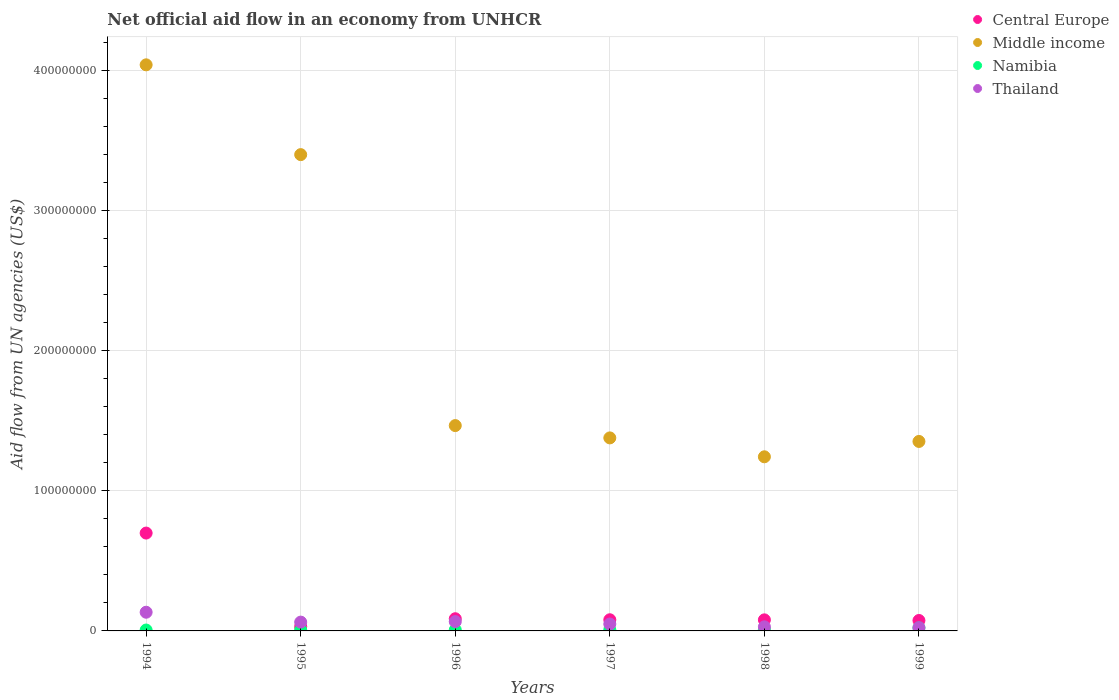What is the net official aid flow in Central Europe in 1995?
Offer a terse response. 3.03e+06. Across all years, what is the maximum net official aid flow in Middle income?
Offer a terse response. 4.04e+08. Across all years, what is the minimum net official aid flow in Namibia?
Provide a short and direct response. 6.40e+05. What is the total net official aid flow in Central Europe in the graph?
Give a very brief answer. 1.05e+08. What is the difference between the net official aid flow in Central Europe in 1994 and the net official aid flow in Middle income in 1999?
Make the answer very short. -6.54e+07. What is the average net official aid flow in Namibia per year?
Your answer should be compact. 1.00e+06. In the year 1997, what is the difference between the net official aid flow in Namibia and net official aid flow in Thailand?
Keep it short and to the point. -4.09e+06. In how many years, is the net official aid flow in Thailand greater than 260000000 US$?
Ensure brevity in your answer.  0. What is the ratio of the net official aid flow in Namibia in 1994 to that in 1999?
Give a very brief answer. 0.29. Is the net official aid flow in Namibia in 1996 less than that in 1999?
Offer a very short reply. Yes. Is the difference between the net official aid flow in Namibia in 1995 and 1997 greater than the difference between the net official aid flow in Thailand in 1995 and 1997?
Provide a short and direct response. No. What is the difference between the highest and the second highest net official aid flow in Namibia?
Your response must be concise. 1.23e+06. What is the difference between the highest and the lowest net official aid flow in Namibia?
Provide a short and direct response. 1.54e+06. Is it the case that in every year, the sum of the net official aid flow in Thailand and net official aid flow in Central Europe  is greater than the sum of net official aid flow in Middle income and net official aid flow in Namibia?
Give a very brief answer. No. Is the net official aid flow in Namibia strictly less than the net official aid flow in Middle income over the years?
Keep it short and to the point. Yes. How many dotlines are there?
Offer a terse response. 4. How many years are there in the graph?
Make the answer very short. 6. What is the difference between two consecutive major ticks on the Y-axis?
Give a very brief answer. 1.00e+08. Are the values on the major ticks of Y-axis written in scientific E-notation?
Offer a very short reply. No. How are the legend labels stacked?
Provide a short and direct response. Vertical. What is the title of the graph?
Provide a short and direct response. Net official aid flow in an economy from UNHCR. Does "Turks and Caicos Islands" appear as one of the legend labels in the graph?
Offer a very short reply. No. What is the label or title of the Y-axis?
Your answer should be very brief. Aid flow from UN agencies (US$). What is the Aid flow from UN agencies (US$) in Central Europe in 1994?
Give a very brief answer. 6.98e+07. What is the Aid flow from UN agencies (US$) in Middle income in 1994?
Ensure brevity in your answer.  4.04e+08. What is the Aid flow from UN agencies (US$) in Namibia in 1994?
Offer a very short reply. 6.40e+05. What is the Aid flow from UN agencies (US$) in Thailand in 1994?
Provide a succinct answer. 1.33e+07. What is the Aid flow from UN agencies (US$) of Central Europe in 1995?
Offer a very short reply. 3.03e+06. What is the Aid flow from UN agencies (US$) in Middle income in 1995?
Provide a succinct answer. 3.40e+08. What is the Aid flow from UN agencies (US$) of Namibia in 1995?
Give a very brief answer. 6.70e+05. What is the Aid flow from UN agencies (US$) of Thailand in 1995?
Your answer should be compact. 6.29e+06. What is the Aid flow from UN agencies (US$) in Central Europe in 1996?
Your answer should be very brief. 8.70e+06. What is the Aid flow from UN agencies (US$) of Middle income in 1996?
Your answer should be very brief. 1.47e+08. What is the Aid flow from UN agencies (US$) in Namibia in 1996?
Your answer should be very brief. 7.50e+05. What is the Aid flow from UN agencies (US$) in Thailand in 1996?
Offer a very short reply. 6.65e+06. What is the Aid flow from UN agencies (US$) in Central Europe in 1997?
Provide a succinct answer. 7.97e+06. What is the Aid flow from UN agencies (US$) in Middle income in 1997?
Make the answer very short. 1.38e+08. What is the Aid flow from UN agencies (US$) in Namibia in 1997?
Make the answer very short. 8.30e+05. What is the Aid flow from UN agencies (US$) of Thailand in 1997?
Make the answer very short. 4.92e+06. What is the Aid flow from UN agencies (US$) of Central Europe in 1998?
Give a very brief answer. 7.90e+06. What is the Aid flow from UN agencies (US$) in Middle income in 1998?
Ensure brevity in your answer.  1.24e+08. What is the Aid flow from UN agencies (US$) in Namibia in 1998?
Your answer should be compact. 9.50e+05. What is the Aid flow from UN agencies (US$) in Thailand in 1998?
Provide a succinct answer. 2.92e+06. What is the Aid flow from UN agencies (US$) in Central Europe in 1999?
Offer a very short reply. 7.45e+06. What is the Aid flow from UN agencies (US$) of Middle income in 1999?
Keep it short and to the point. 1.35e+08. What is the Aid flow from UN agencies (US$) in Namibia in 1999?
Give a very brief answer. 2.18e+06. What is the Aid flow from UN agencies (US$) in Thailand in 1999?
Provide a short and direct response. 2.33e+06. Across all years, what is the maximum Aid flow from UN agencies (US$) of Central Europe?
Your answer should be compact. 6.98e+07. Across all years, what is the maximum Aid flow from UN agencies (US$) of Middle income?
Give a very brief answer. 4.04e+08. Across all years, what is the maximum Aid flow from UN agencies (US$) in Namibia?
Provide a succinct answer. 2.18e+06. Across all years, what is the maximum Aid flow from UN agencies (US$) of Thailand?
Your answer should be compact. 1.33e+07. Across all years, what is the minimum Aid flow from UN agencies (US$) of Central Europe?
Keep it short and to the point. 3.03e+06. Across all years, what is the minimum Aid flow from UN agencies (US$) of Middle income?
Give a very brief answer. 1.24e+08. Across all years, what is the minimum Aid flow from UN agencies (US$) in Namibia?
Provide a short and direct response. 6.40e+05. Across all years, what is the minimum Aid flow from UN agencies (US$) of Thailand?
Offer a very short reply. 2.33e+06. What is the total Aid flow from UN agencies (US$) of Central Europe in the graph?
Give a very brief answer. 1.05e+08. What is the total Aid flow from UN agencies (US$) in Middle income in the graph?
Your answer should be very brief. 1.29e+09. What is the total Aid flow from UN agencies (US$) of Namibia in the graph?
Provide a succinct answer. 6.02e+06. What is the total Aid flow from UN agencies (US$) of Thailand in the graph?
Provide a succinct answer. 3.64e+07. What is the difference between the Aid flow from UN agencies (US$) in Central Europe in 1994 and that in 1995?
Provide a short and direct response. 6.68e+07. What is the difference between the Aid flow from UN agencies (US$) of Middle income in 1994 and that in 1995?
Offer a very short reply. 6.41e+07. What is the difference between the Aid flow from UN agencies (US$) of Namibia in 1994 and that in 1995?
Offer a very short reply. -3.00e+04. What is the difference between the Aid flow from UN agencies (US$) in Thailand in 1994 and that in 1995?
Provide a short and direct response. 7.05e+06. What is the difference between the Aid flow from UN agencies (US$) of Central Europe in 1994 and that in 1996?
Your response must be concise. 6.12e+07. What is the difference between the Aid flow from UN agencies (US$) in Middle income in 1994 and that in 1996?
Your answer should be compact. 2.58e+08. What is the difference between the Aid flow from UN agencies (US$) of Namibia in 1994 and that in 1996?
Give a very brief answer. -1.10e+05. What is the difference between the Aid flow from UN agencies (US$) in Thailand in 1994 and that in 1996?
Offer a very short reply. 6.69e+06. What is the difference between the Aid flow from UN agencies (US$) in Central Europe in 1994 and that in 1997?
Offer a terse response. 6.19e+07. What is the difference between the Aid flow from UN agencies (US$) of Middle income in 1994 and that in 1997?
Make the answer very short. 2.66e+08. What is the difference between the Aid flow from UN agencies (US$) in Thailand in 1994 and that in 1997?
Ensure brevity in your answer.  8.42e+06. What is the difference between the Aid flow from UN agencies (US$) in Central Europe in 1994 and that in 1998?
Make the answer very short. 6.20e+07. What is the difference between the Aid flow from UN agencies (US$) in Middle income in 1994 and that in 1998?
Your answer should be compact. 2.80e+08. What is the difference between the Aid flow from UN agencies (US$) of Namibia in 1994 and that in 1998?
Give a very brief answer. -3.10e+05. What is the difference between the Aid flow from UN agencies (US$) in Thailand in 1994 and that in 1998?
Your answer should be very brief. 1.04e+07. What is the difference between the Aid flow from UN agencies (US$) in Central Europe in 1994 and that in 1999?
Offer a very short reply. 6.24e+07. What is the difference between the Aid flow from UN agencies (US$) in Middle income in 1994 and that in 1999?
Your answer should be very brief. 2.69e+08. What is the difference between the Aid flow from UN agencies (US$) of Namibia in 1994 and that in 1999?
Provide a short and direct response. -1.54e+06. What is the difference between the Aid flow from UN agencies (US$) of Thailand in 1994 and that in 1999?
Ensure brevity in your answer.  1.10e+07. What is the difference between the Aid flow from UN agencies (US$) of Central Europe in 1995 and that in 1996?
Ensure brevity in your answer.  -5.67e+06. What is the difference between the Aid flow from UN agencies (US$) of Middle income in 1995 and that in 1996?
Give a very brief answer. 1.93e+08. What is the difference between the Aid flow from UN agencies (US$) in Thailand in 1995 and that in 1996?
Provide a succinct answer. -3.60e+05. What is the difference between the Aid flow from UN agencies (US$) of Central Europe in 1995 and that in 1997?
Offer a very short reply. -4.94e+06. What is the difference between the Aid flow from UN agencies (US$) of Middle income in 1995 and that in 1997?
Give a very brief answer. 2.02e+08. What is the difference between the Aid flow from UN agencies (US$) of Thailand in 1995 and that in 1997?
Your answer should be compact. 1.37e+06. What is the difference between the Aid flow from UN agencies (US$) of Central Europe in 1995 and that in 1998?
Your answer should be very brief. -4.87e+06. What is the difference between the Aid flow from UN agencies (US$) in Middle income in 1995 and that in 1998?
Your answer should be very brief. 2.16e+08. What is the difference between the Aid flow from UN agencies (US$) of Namibia in 1995 and that in 1998?
Your response must be concise. -2.80e+05. What is the difference between the Aid flow from UN agencies (US$) in Thailand in 1995 and that in 1998?
Make the answer very short. 3.37e+06. What is the difference between the Aid flow from UN agencies (US$) in Central Europe in 1995 and that in 1999?
Provide a short and direct response. -4.42e+06. What is the difference between the Aid flow from UN agencies (US$) in Middle income in 1995 and that in 1999?
Your answer should be very brief. 2.05e+08. What is the difference between the Aid flow from UN agencies (US$) in Namibia in 1995 and that in 1999?
Keep it short and to the point. -1.51e+06. What is the difference between the Aid flow from UN agencies (US$) of Thailand in 1995 and that in 1999?
Offer a terse response. 3.96e+06. What is the difference between the Aid flow from UN agencies (US$) of Central Europe in 1996 and that in 1997?
Provide a succinct answer. 7.30e+05. What is the difference between the Aid flow from UN agencies (US$) of Middle income in 1996 and that in 1997?
Offer a very short reply. 8.79e+06. What is the difference between the Aid flow from UN agencies (US$) of Thailand in 1996 and that in 1997?
Keep it short and to the point. 1.73e+06. What is the difference between the Aid flow from UN agencies (US$) in Middle income in 1996 and that in 1998?
Make the answer very short. 2.23e+07. What is the difference between the Aid flow from UN agencies (US$) of Thailand in 1996 and that in 1998?
Offer a terse response. 3.73e+06. What is the difference between the Aid flow from UN agencies (US$) of Central Europe in 1996 and that in 1999?
Give a very brief answer. 1.25e+06. What is the difference between the Aid flow from UN agencies (US$) in Middle income in 1996 and that in 1999?
Your answer should be compact. 1.13e+07. What is the difference between the Aid flow from UN agencies (US$) in Namibia in 1996 and that in 1999?
Offer a terse response. -1.43e+06. What is the difference between the Aid flow from UN agencies (US$) of Thailand in 1996 and that in 1999?
Your answer should be very brief. 4.32e+06. What is the difference between the Aid flow from UN agencies (US$) in Central Europe in 1997 and that in 1998?
Offer a terse response. 7.00e+04. What is the difference between the Aid flow from UN agencies (US$) of Middle income in 1997 and that in 1998?
Your answer should be compact. 1.35e+07. What is the difference between the Aid flow from UN agencies (US$) of Thailand in 1997 and that in 1998?
Give a very brief answer. 2.00e+06. What is the difference between the Aid flow from UN agencies (US$) in Central Europe in 1997 and that in 1999?
Your response must be concise. 5.20e+05. What is the difference between the Aid flow from UN agencies (US$) in Middle income in 1997 and that in 1999?
Give a very brief answer. 2.53e+06. What is the difference between the Aid flow from UN agencies (US$) of Namibia in 1997 and that in 1999?
Give a very brief answer. -1.35e+06. What is the difference between the Aid flow from UN agencies (US$) of Thailand in 1997 and that in 1999?
Provide a short and direct response. 2.59e+06. What is the difference between the Aid flow from UN agencies (US$) in Middle income in 1998 and that in 1999?
Your answer should be very brief. -1.10e+07. What is the difference between the Aid flow from UN agencies (US$) in Namibia in 1998 and that in 1999?
Your answer should be compact. -1.23e+06. What is the difference between the Aid flow from UN agencies (US$) of Thailand in 1998 and that in 1999?
Offer a terse response. 5.90e+05. What is the difference between the Aid flow from UN agencies (US$) of Central Europe in 1994 and the Aid flow from UN agencies (US$) of Middle income in 1995?
Offer a terse response. -2.70e+08. What is the difference between the Aid flow from UN agencies (US$) of Central Europe in 1994 and the Aid flow from UN agencies (US$) of Namibia in 1995?
Offer a terse response. 6.92e+07. What is the difference between the Aid flow from UN agencies (US$) of Central Europe in 1994 and the Aid flow from UN agencies (US$) of Thailand in 1995?
Your answer should be very brief. 6.36e+07. What is the difference between the Aid flow from UN agencies (US$) of Middle income in 1994 and the Aid flow from UN agencies (US$) of Namibia in 1995?
Provide a short and direct response. 4.03e+08. What is the difference between the Aid flow from UN agencies (US$) in Middle income in 1994 and the Aid flow from UN agencies (US$) in Thailand in 1995?
Offer a terse response. 3.98e+08. What is the difference between the Aid flow from UN agencies (US$) of Namibia in 1994 and the Aid flow from UN agencies (US$) of Thailand in 1995?
Give a very brief answer. -5.65e+06. What is the difference between the Aid flow from UN agencies (US$) of Central Europe in 1994 and the Aid flow from UN agencies (US$) of Middle income in 1996?
Provide a short and direct response. -7.67e+07. What is the difference between the Aid flow from UN agencies (US$) in Central Europe in 1994 and the Aid flow from UN agencies (US$) in Namibia in 1996?
Make the answer very short. 6.91e+07. What is the difference between the Aid flow from UN agencies (US$) of Central Europe in 1994 and the Aid flow from UN agencies (US$) of Thailand in 1996?
Your answer should be compact. 6.32e+07. What is the difference between the Aid flow from UN agencies (US$) in Middle income in 1994 and the Aid flow from UN agencies (US$) in Namibia in 1996?
Ensure brevity in your answer.  4.03e+08. What is the difference between the Aid flow from UN agencies (US$) of Middle income in 1994 and the Aid flow from UN agencies (US$) of Thailand in 1996?
Provide a succinct answer. 3.97e+08. What is the difference between the Aid flow from UN agencies (US$) in Namibia in 1994 and the Aid flow from UN agencies (US$) in Thailand in 1996?
Your response must be concise. -6.01e+06. What is the difference between the Aid flow from UN agencies (US$) of Central Europe in 1994 and the Aid flow from UN agencies (US$) of Middle income in 1997?
Offer a very short reply. -6.79e+07. What is the difference between the Aid flow from UN agencies (US$) in Central Europe in 1994 and the Aid flow from UN agencies (US$) in Namibia in 1997?
Your response must be concise. 6.90e+07. What is the difference between the Aid flow from UN agencies (US$) of Central Europe in 1994 and the Aid flow from UN agencies (US$) of Thailand in 1997?
Ensure brevity in your answer.  6.49e+07. What is the difference between the Aid flow from UN agencies (US$) in Middle income in 1994 and the Aid flow from UN agencies (US$) in Namibia in 1997?
Ensure brevity in your answer.  4.03e+08. What is the difference between the Aid flow from UN agencies (US$) in Middle income in 1994 and the Aid flow from UN agencies (US$) in Thailand in 1997?
Provide a succinct answer. 3.99e+08. What is the difference between the Aid flow from UN agencies (US$) in Namibia in 1994 and the Aid flow from UN agencies (US$) in Thailand in 1997?
Ensure brevity in your answer.  -4.28e+06. What is the difference between the Aid flow from UN agencies (US$) in Central Europe in 1994 and the Aid flow from UN agencies (US$) in Middle income in 1998?
Offer a very short reply. -5.44e+07. What is the difference between the Aid flow from UN agencies (US$) of Central Europe in 1994 and the Aid flow from UN agencies (US$) of Namibia in 1998?
Your answer should be compact. 6.89e+07. What is the difference between the Aid flow from UN agencies (US$) of Central Europe in 1994 and the Aid flow from UN agencies (US$) of Thailand in 1998?
Offer a terse response. 6.69e+07. What is the difference between the Aid flow from UN agencies (US$) in Middle income in 1994 and the Aid flow from UN agencies (US$) in Namibia in 1998?
Give a very brief answer. 4.03e+08. What is the difference between the Aid flow from UN agencies (US$) of Middle income in 1994 and the Aid flow from UN agencies (US$) of Thailand in 1998?
Your answer should be compact. 4.01e+08. What is the difference between the Aid flow from UN agencies (US$) in Namibia in 1994 and the Aid flow from UN agencies (US$) in Thailand in 1998?
Provide a short and direct response. -2.28e+06. What is the difference between the Aid flow from UN agencies (US$) of Central Europe in 1994 and the Aid flow from UN agencies (US$) of Middle income in 1999?
Ensure brevity in your answer.  -6.54e+07. What is the difference between the Aid flow from UN agencies (US$) of Central Europe in 1994 and the Aid flow from UN agencies (US$) of Namibia in 1999?
Your answer should be very brief. 6.77e+07. What is the difference between the Aid flow from UN agencies (US$) in Central Europe in 1994 and the Aid flow from UN agencies (US$) in Thailand in 1999?
Your answer should be compact. 6.75e+07. What is the difference between the Aid flow from UN agencies (US$) of Middle income in 1994 and the Aid flow from UN agencies (US$) of Namibia in 1999?
Offer a very short reply. 4.02e+08. What is the difference between the Aid flow from UN agencies (US$) of Middle income in 1994 and the Aid flow from UN agencies (US$) of Thailand in 1999?
Your answer should be compact. 4.02e+08. What is the difference between the Aid flow from UN agencies (US$) in Namibia in 1994 and the Aid flow from UN agencies (US$) in Thailand in 1999?
Provide a succinct answer. -1.69e+06. What is the difference between the Aid flow from UN agencies (US$) in Central Europe in 1995 and the Aid flow from UN agencies (US$) in Middle income in 1996?
Your answer should be very brief. -1.44e+08. What is the difference between the Aid flow from UN agencies (US$) of Central Europe in 1995 and the Aid flow from UN agencies (US$) of Namibia in 1996?
Provide a short and direct response. 2.28e+06. What is the difference between the Aid flow from UN agencies (US$) in Central Europe in 1995 and the Aid flow from UN agencies (US$) in Thailand in 1996?
Provide a short and direct response. -3.62e+06. What is the difference between the Aid flow from UN agencies (US$) of Middle income in 1995 and the Aid flow from UN agencies (US$) of Namibia in 1996?
Your response must be concise. 3.39e+08. What is the difference between the Aid flow from UN agencies (US$) in Middle income in 1995 and the Aid flow from UN agencies (US$) in Thailand in 1996?
Offer a very short reply. 3.33e+08. What is the difference between the Aid flow from UN agencies (US$) in Namibia in 1995 and the Aid flow from UN agencies (US$) in Thailand in 1996?
Your response must be concise. -5.98e+06. What is the difference between the Aid flow from UN agencies (US$) in Central Europe in 1995 and the Aid flow from UN agencies (US$) in Middle income in 1997?
Offer a terse response. -1.35e+08. What is the difference between the Aid flow from UN agencies (US$) of Central Europe in 1995 and the Aid flow from UN agencies (US$) of Namibia in 1997?
Ensure brevity in your answer.  2.20e+06. What is the difference between the Aid flow from UN agencies (US$) of Central Europe in 1995 and the Aid flow from UN agencies (US$) of Thailand in 1997?
Give a very brief answer. -1.89e+06. What is the difference between the Aid flow from UN agencies (US$) of Middle income in 1995 and the Aid flow from UN agencies (US$) of Namibia in 1997?
Offer a terse response. 3.39e+08. What is the difference between the Aid flow from UN agencies (US$) in Middle income in 1995 and the Aid flow from UN agencies (US$) in Thailand in 1997?
Offer a very short reply. 3.35e+08. What is the difference between the Aid flow from UN agencies (US$) of Namibia in 1995 and the Aid flow from UN agencies (US$) of Thailand in 1997?
Your response must be concise. -4.25e+06. What is the difference between the Aid flow from UN agencies (US$) in Central Europe in 1995 and the Aid flow from UN agencies (US$) in Middle income in 1998?
Your answer should be very brief. -1.21e+08. What is the difference between the Aid flow from UN agencies (US$) in Central Europe in 1995 and the Aid flow from UN agencies (US$) in Namibia in 1998?
Provide a short and direct response. 2.08e+06. What is the difference between the Aid flow from UN agencies (US$) of Middle income in 1995 and the Aid flow from UN agencies (US$) of Namibia in 1998?
Make the answer very short. 3.39e+08. What is the difference between the Aid flow from UN agencies (US$) of Middle income in 1995 and the Aid flow from UN agencies (US$) of Thailand in 1998?
Your response must be concise. 3.37e+08. What is the difference between the Aid flow from UN agencies (US$) of Namibia in 1995 and the Aid flow from UN agencies (US$) of Thailand in 1998?
Give a very brief answer. -2.25e+06. What is the difference between the Aid flow from UN agencies (US$) in Central Europe in 1995 and the Aid flow from UN agencies (US$) in Middle income in 1999?
Offer a very short reply. -1.32e+08. What is the difference between the Aid flow from UN agencies (US$) in Central Europe in 1995 and the Aid flow from UN agencies (US$) in Namibia in 1999?
Provide a succinct answer. 8.50e+05. What is the difference between the Aid flow from UN agencies (US$) in Central Europe in 1995 and the Aid flow from UN agencies (US$) in Thailand in 1999?
Your answer should be very brief. 7.00e+05. What is the difference between the Aid flow from UN agencies (US$) in Middle income in 1995 and the Aid flow from UN agencies (US$) in Namibia in 1999?
Make the answer very short. 3.38e+08. What is the difference between the Aid flow from UN agencies (US$) of Middle income in 1995 and the Aid flow from UN agencies (US$) of Thailand in 1999?
Keep it short and to the point. 3.38e+08. What is the difference between the Aid flow from UN agencies (US$) in Namibia in 1995 and the Aid flow from UN agencies (US$) in Thailand in 1999?
Offer a very short reply. -1.66e+06. What is the difference between the Aid flow from UN agencies (US$) of Central Europe in 1996 and the Aid flow from UN agencies (US$) of Middle income in 1997?
Offer a very short reply. -1.29e+08. What is the difference between the Aid flow from UN agencies (US$) in Central Europe in 1996 and the Aid flow from UN agencies (US$) in Namibia in 1997?
Provide a short and direct response. 7.87e+06. What is the difference between the Aid flow from UN agencies (US$) of Central Europe in 1996 and the Aid flow from UN agencies (US$) of Thailand in 1997?
Your response must be concise. 3.78e+06. What is the difference between the Aid flow from UN agencies (US$) of Middle income in 1996 and the Aid flow from UN agencies (US$) of Namibia in 1997?
Keep it short and to the point. 1.46e+08. What is the difference between the Aid flow from UN agencies (US$) of Middle income in 1996 and the Aid flow from UN agencies (US$) of Thailand in 1997?
Your response must be concise. 1.42e+08. What is the difference between the Aid flow from UN agencies (US$) of Namibia in 1996 and the Aid flow from UN agencies (US$) of Thailand in 1997?
Provide a short and direct response. -4.17e+06. What is the difference between the Aid flow from UN agencies (US$) in Central Europe in 1996 and the Aid flow from UN agencies (US$) in Middle income in 1998?
Ensure brevity in your answer.  -1.16e+08. What is the difference between the Aid flow from UN agencies (US$) of Central Europe in 1996 and the Aid flow from UN agencies (US$) of Namibia in 1998?
Provide a short and direct response. 7.75e+06. What is the difference between the Aid flow from UN agencies (US$) in Central Europe in 1996 and the Aid flow from UN agencies (US$) in Thailand in 1998?
Give a very brief answer. 5.78e+06. What is the difference between the Aid flow from UN agencies (US$) in Middle income in 1996 and the Aid flow from UN agencies (US$) in Namibia in 1998?
Ensure brevity in your answer.  1.46e+08. What is the difference between the Aid flow from UN agencies (US$) in Middle income in 1996 and the Aid flow from UN agencies (US$) in Thailand in 1998?
Provide a short and direct response. 1.44e+08. What is the difference between the Aid flow from UN agencies (US$) of Namibia in 1996 and the Aid flow from UN agencies (US$) of Thailand in 1998?
Your answer should be compact. -2.17e+06. What is the difference between the Aid flow from UN agencies (US$) in Central Europe in 1996 and the Aid flow from UN agencies (US$) in Middle income in 1999?
Provide a short and direct response. -1.27e+08. What is the difference between the Aid flow from UN agencies (US$) in Central Europe in 1996 and the Aid flow from UN agencies (US$) in Namibia in 1999?
Your answer should be very brief. 6.52e+06. What is the difference between the Aid flow from UN agencies (US$) of Central Europe in 1996 and the Aid flow from UN agencies (US$) of Thailand in 1999?
Your response must be concise. 6.37e+06. What is the difference between the Aid flow from UN agencies (US$) in Middle income in 1996 and the Aid flow from UN agencies (US$) in Namibia in 1999?
Offer a terse response. 1.44e+08. What is the difference between the Aid flow from UN agencies (US$) in Middle income in 1996 and the Aid flow from UN agencies (US$) in Thailand in 1999?
Keep it short and to the point. 1.44e+08. What is the difference between the Aid flow from UN agencies (US$) of Namibia in 1996 and the Aid flow from UN agencies (US$) of Thailand in 1999?
Ensure brevity in your answer.  -1.58e+06. What is the difference between the Aid flow from UN agencies (US$) in Central Europe in 1997 and the Aid flow from UN agencies (US$) in Middle income in 1998?
Keep it short and to the point. -1.16e+08. What is the difference between the Aid flow from UN agencies (US$) in Central Europe in 1997 and the Aid flow from UN agencies (US$) in Namibia in 1998?
Offer a terse response. 7.02e+06. What is the difference between the Aid flow from UN agencies (US$) of Central Europe in 1997 and the Aid flow from UN agencies (US$) of Thailand in 1998?
Keep it short and to the point. 5.05e+06. What is the difference between the Aid flow from UN agencies (US$) in Middle income in 1997 and the Aid flow from UN agencies (US$) in Namibia in 1998?
Provide a succinct answer. 1.37e+08. What is the difference between the Aid flow from UN agencies (US$) in Middle income in 1997 and the Aid flow from UN agencies (US$) in Thailand in 1998?
Your response must be concise. 1.35e+08. What is the difference between the Aid flow from UN agencies (US$) in Namibia in 1997 and the Aid flow from UN agencies (US$) in Thailand in 1998?
Your answer should be compact. -2.09e+06. What is the difference between the Aid flow from UN agencies (US$) of Central Europe in 1997 and the Aid flow from UN agencies (US$) of Middle income in 1999?
Provide a short and direct response. -1.27e+08. What is the difference between the Aid flow from UN agencies (US$) of Central Europe in 1997 and the Aid flow from UN agencies (US$) of Namibia in 1999?
Keep it short and to the point. 5.79e+06. What is the difference between the Aid flow from UN agencies (US$) of Central Europe in 1997 and the Aid flow from UN agencies (US$) of Thailand in 1999?
Make the answer very short. 5.64e+06. What is the difference between the Aid flow from UN agencies (US$) of Middle income in 1997 and the Aid flow from UN agencies (US$) of Namibia in 1999?
Ensure brevity in your answer.  1.36e+08. What is the difference between the Aid flow from UN agencies (US$) of Middle income in 1997 and the Aid flow from UN agencies (US$) of Thailand in 1999?
Your response must be concise. 1.35e+08. What is the difference between the Aid flow from UN agencies (US$) in Namibia in 1997 and the Aid flow from UN agencies (US$) in Thailand in 1999?
Offer a terse response. -1.50e+06. What is the difference between the Aid flow from UN agencies (US$) in Central Europe in 1998 and the Aid flow from UN agencies (US$) in Middle income in 1999?
Offer a very short reply. -1.27e+08. What is the difference between the Aid flow from UN agencies (US$) of Central Europe in 1998 and the Aid flow from UN agencies (US$) of Namibia in 1999?
Offer a terse response. 5.72e+06. What is the difference between the Aid flow from UN agencies (US$) in Central Europe in 1998 and the Aid flow from UN agencies (US$) in Thailand in 1999?
Your response must be concise. 5.57e+06. What is the difference between the Aid flow from UN agencies (US$) of Middle income in 1998 and the Aid flow from UN agencies (US$) of Namibia in 1999?
Make the answer very short. 1.22e+08. What is the difference between the Aid flow from UN agencies (US$) of Middle income in 1998 and the Aid flow from UN agencies (US$) of Thailand in 1999?
Your answer should be compact. 1.22e+08. What is the difference between the Aid flow from UN agencies (US$) in Namibia in 1998 and the Aid flow from UN agencies (US$) in Thailand in 1999?
Make the answer very short. -1.38e+06. What is the average Aid flow from UN agencies (US$) of Central Europe per year?
Give a very brief answer. 1.75e+07. What is the average Aid flow from UN agencies (US$) of Middle income per year?
Make the answer very short. 2.15e+08. What is the average Aid flow from UN agencies (US$) of Namibia per year?
Make the answer very short. 1.00e+06. What is the average Aid flow from UN agencies (US$) of Thailand per year?
Offer a terse response. 6.08e+06. In the year 1994, what is the difference between the Aid flow from UN agencies (US$) of Central Europe and Aid flow from UN agencies (US$) of Middle income?
Give a very brief answer. -3.34e+08. In the year 1994, what is the difference between the Aid flow from UN agencies (US$) of Central Europe and Aid flow from UN agencies (US$) of Namibia?
Keep it short and to the point. 6.92e+07. In the year 1994, what is the difference between the Aid flow from UN agencies (US$) in Central Europe and Aid flow from UN agencies (US$) in Thailand?
Offer a very short reply. 5.65e+07. In the year 1994, what is the difference between the Aid flow from UN agencies (US$) in Middle income and Aid flow from UN agencies (US$) in Namibia?
Your response must be concise. 4.03e+08. In the year 1994, what is the difference between the Aid flow from UN agencies (US$) in Middle income and Aid flow from UN agencies (US$) in Thailand?
Ensure brevity in your answer.  3.91e+08. In the year 1994, what is the difference between the Aid flow from UN agencies (US$) in Namibia and Aid flow from UN agencies (US$) in Thailand?
Provide a short and direct response. -1.27e+07. In the year 1995, what is the difference between the Aid flow from UN agencies (US$) in Central Europe and Aid flow from UN agencies (US$) in Middle income?
Provide a succinct answer. -3.37e+08. In the year 1995, what is the difference between the Aid flow from UN agencies (US$) of Central Europe and Aid flow from UN agencies (US$) of Namibia?
Your answer should be very brief. 2.36e+06. In the year 1995, what is the difference between the Aid flow from UN agencies (US$) of Central Europe and Aid flow from UN agencies (US$) of Thailand?
Make the answer very short. -3.26e+06. In the year 1995, what is the difference between the Aid flow from UN agencies (US$) of Middle income and Aid flow from UN agencies (US$) of Namibia?
Provide a short and direct response. 3.39e+08. In the year 1995, what is the difference between the Aid flow from UN agencies (US$) in Middle income and Aid flow from UN agencies (US$) in Thailand?
Your answer should be compact. 3.34e+08. In the year 1995, what is the difference between the Aid flow from UN agencies (US$) in Namibia and Aid flow from UN agencies (US$) in Thailand?
Keep it short and to the point. -5.62e+06. In the year 1996, what is the difference between the Aid flow from UN agencies (US$) in Central Europe and Aid flow from UN agencies (US$) in Middle income?
Provide a succinct answer. -1.38e+08. In the year 1996, what is the difference between the Aid flow from UN agencies (US$) of Central Europe and Aid flow from UN agencies (US$) of Namibia?
Your answer should be compact. 7.95e+06. In the year 1996, what is the difference between the Aid flow from UN agencies (US$) in Central Europe and Aid flow from UN agencies (US$) in Thailand?
Provide a short and direct response. 2.05e+06. In the year 1996, what is the difference between the Aid flow from UN agencies (US$) in Middle income and Aid flow from UN agencies (US$) in Namibia?
Ensure brevity in your answer.  1.46e+08. In the year 1996, what is the difference between the Aid flow from UN agencies (US$) in Middle income and Aid flow from UN agencies (US$) in Thailand?
Offer a terse response. 1.40e+08. In the year 1996, what is the difference between the Aid flow from UN agencies (US$) in Namibia and Aid flow from UN agencies (US$) in Thailand?
Offer a terse response. -5.90e+06. In the year 1997, what is the difference between the Aid flow from UN agencies (US$) in Central Europe and Aid flow from UN agencies (US$) in Middle income?
Your answer should be very brief. -1.30e+08. In the year 1997, what is the difference between the Aid flow from UN agencies (US$) of Central Europe and Aid flow from UN agencies (US$) of Namibia?
Provide a short and direct response. 7.14e+06. In the year 1997, what is the difference between the Aid flow from UN agencies (US$) in Central Europe and Aid flow from UN agencies (US$) in Thailand?
Make the answer very short. 3.05e+06. In the year 1997, what is the difference between the Aid flow from UN agencies (US$) in Middle income and Aid flow from UN agencies (US$) in Namibia?
Provide a short and direct response. 1.37e+08. In the year 1997, what is the difference between the Aid flow from UN agencies (US$) of Middle income and Aid flow from UN agencies (US$) of Thailand?
Offer a terse response. 1.33e+08. In the year 1997, what is the difference between the Aid flow from UN agencies (US$) in Namibia and Aid flow from UN agencies (US$) in Thailand?
Your response must be concise. -4.09e+06. In the year 1998, what is the difference between the Aid flow from UN agencies (US$) of Central Europe and Aid flow from UN agencies (US$) of Middle income?
Your answer should be very brief. -1.16e+08. In the year 1998, what is the difference between the Aid flow from UN agencies (US$) of Central Europe and Aid flow from UN agencies (US$) of Namibia?
Offer a very short reply. 6.95e+06. In the year 1998, what is the difference between the Aid flow from UN agencies (US$) in Central Europe and Aid flow from UN agencies (US$) in Thailand?
Make the answer very short. 4.98e+06. In the year 1998, what is the difference between the Aid flow from UN agencies (US$) of Middle income and Aid flow from UN agencies (US$) of Namibia?
Make the answer very short. 1.23e+08. In the year 1998, what is the difference between the Aid flow from UN agencies (US$) in Middle income and Aid flow from UN agencies (US$) in Thailand?
Keep it short and to the point. 1.21e+08. In the year 1998, what is the difference between the Aid flow from UN agencies (US$) of Namibia and Aid flow from UN agencies (US$) of Thailand?
Your answer should be very brief. -1.97e+06. In the year 1999, what is the difference between the Aid flow from UN agencies (US$) of Central Europe and Aid flow from UN agencies (US$) of Middle income?
Provide a succinct answer. -1.28e+08. In the year 1999, what is the difference between the Aid flow from UN agencies (US$) in Central Europe and Aid flow from UN agencies (US$) in Namibia?
Provide a succinct answer. 5.27e+06. In the year 1999, what is the difference between the Aid flow from UN agencies (US$) in Central Europe and Aid flow from UN agencies (US$) in Thailand?
Your response must be concise. 5.12e+06. In the year 1999, what is the difference between the Aid flow from UN agencies (US$) of Middle income and Aid flow from UN agencies (US$) of Namibia?
Offer a very short reply. 1.33e+08. In the year 1999, what is the difference between the Aid flow from UN agencies (US$) of Middle income and Aid flow from UN agencies (US$) of Thailand?
Your response must be concise. 1.33e+08. In the year 1999, what is the difference between the Aid flow from UN agencies (US$) of Namibia and Aid flow from UN agencies (US$) of Thailand?
Provide a short and direct response. -1.50e+05. What is the ratio of the Aid flow from UN agencies (US$) of Central Europe in 1994 to that in 1995?
Ensure brevity in your answer.  23.05. What is the ratio of the Aid flow from UN agencies (US$) of Middle income in 1994 to that in 1995?
Give a very brief answer. 1.19. What is the ratio of the Aid flow from UN agencies (US$) in Namibia in 1994 to that in 1995?
Keep it short and to the point. 0.96. What is the ratio of the Aid flow from UN agencies (US$) of Thailand in 1994 to that in 1995?
Provide a short and direct response. 2.12. What is the ratio of the Aid flow from UN agencies (US$) in Central Europe in 1994 to that in 1996?
Give a very brief answer. 8.03. What is the ratio of the Aid flow from UN agencies (US$) of Middle income in 1994 to that in 1996?
Your response must be concise. 2.76. What is the ratio of the Aid flow from UN agencies (US$) in Namibia in 1994 to that in 1996?
Offer a terse response. 0.85. What is the ratio of the Aid flow from UN agencies (US$) in Thailand in 1994 to that in 1996?
Your answer should be very brief. 2.01. What is the ratio of the Aid flow from UN agencies (US$) of Central Europe in 1994 to that in 1997?
Give a very brief answer. 8.76. What is the ratio of the Aid flow from UN agencies (US$) of Middle income in 1994 to that in 1997?
Make the answer very short. 2.93. What is the ratio of the Aid flow from UN agencies (US$) of Namibia in 1994 to that in 1997?
Offer a very short reply. 0.77. What is the ratio of the Aid flow from UN agencies (US$) in Thailand in 1994 to that in 1997?
Ensure brevity in your answer.  2.71. What is the ratio of the Aid flow from UN agencies (US$) of Central Europe in 1994 to that in 1998?
Your response must be concise. 8.84. What is the ratio of the Aid flow from UN agencies (US$) in Middle income in 1994 to that in 1998?
Give a very brief answer. 3.25. What is the ratio of the Aid flow from UN agencies (US$) of Namibia in 1994 to that in 1998?
Your answer should be compact. 0.67. What is the ratio of the Aid flow from UN agencies (US$) of Thailand in 1994 to that in 1998?
Ensure brevity in your answer.  4.57. What is the ratio of the Aid flow from UN agencies (US$) of Central Europe in 1994 to that in 1999?
Offer a very short reply. 9.38. What is the ratio of the Aid flow from UN agencies (US$) of Middle income in 1994 to that in 1999?
Give a very brief answer. 2.99. What is the ratio of the Aid flow from UN agencies (US$) of Namibia in 1994 to that in 1999?
Ensure brevity in your answer.  0.29. What is the ratio of the Aid flow from UN agencies (US$) of Thailand in 1994 to that in 1999?
Provide a short and direct response. 5.73. What is the ratio of the Aid flow from UN agencies (US$) of Central Europe in 1995 to that in 1996?
Keep it short and to the point. 0.35. What is the ratio of the Aid flow from UN agencies (US$) of Middle income in 1995 to that in 1996?
Provide a succinct answer. 2.32. What is the ratio of the Aid flow from UN agencies (US$) in Namibia in 1995 to that in 1996?
Make the answer very short. 0.89. What is the ratio of the Aid flow from UN agencies (US$) in Thailand in 1995 to that in 1996?
Provide a succinct answer. 0.95. What is the ratio of the Aid flow from UN agencies (US$) of Central Europe in 1995 to that in 1997?
Offer a terse response. 0.38. What is the ratio of the Aid flow from UN agencies (US$) in Middle income in 1995 to that in 1997?
Ensure brevity in your answer.  2.47. What is the ratio of the Aid flow from UN agencies (US$) of Namibia in 1995 to that in 1997?
Offer a very short reply. 0.81. What is the ratio of the Aid flow from UN agencies (US$) of Thailand in 1995 to that in 1997?
Provide a succinct answer. 1.28. What is the ratio of the Aid flow from UN agencies (US$) of Central Europe in 1995 to that in 1998?
Your answer should be compact. 0.38. What is the ratio of the Aid flow from UN agencies (US$) of Middle income in 1995 to that in 1998?
Give a very brief answer. 2.74. What is the ratio of the Aid flow from UN agencies (US$) in Namibia in 1995 to that in 1998?
Give a very brief answer. 0.71. What is the ratio of the Aid flow from UN agencies (US$) in Thailand in 1995 to that in 1998?
Make the answer very short. 2.15. What is the ratio of the Aid flow from UN agencies (US$) in Central Europe in 1995 to that in 1999?
Provide a short and direct response. 0.41. What is the ratio of the Aid flow from UN agencies (US$) in Middle income in 1995 to that in 1999?
Provide a short and direct response. 2.51. What is the ratio of the Aid flow from UN agencies (US$) of Namibia in 1995 to that in 1999?
Your answer should be compact. 0.31. What is the ratio of the Aid flow from UN agencies (US$) of Thailand in 1995 to that in 1999?
Offer a very short reply. 2.7. What is the ratio of the Aid flow from UN agencies (US$) of Central Europe in 1996 to that in 1997?
Offer a very short reply. 1.09. What is the ratio of the Aid flow from UN agencies (US$) in Middle income in 1996 to that in 1997?
Your response must be concise. 1.06. What is the ratio of the Aid flow from UN agencies (US$) of Namibia in 1996 to that in 1997?
Provide a succinct answer. 0.9. What is the ratio of the Aid flow from UN agencies (US$) of Thailand in 1996 to that in 1997?
Offer a terse response. 1.35. What is the ratio of the Aid flow from UN agencies (US$) of Central Europe in 1996 to that in 1998?
Provide a succinct answer. 1.1. What is the ratio of the Aid flow from UN agencies (US$) in Middle income in 1996 to that in 1998?
Provide a short and direct response. 1.18. What is the ratio of the Aid flow from UN agencies (US$) of Namibia in 1996 to that in 1998?
Offer a very short reply. 0.79. What is the ratio of the Aid flow from UN agencies (US$) in Thailand in 1996 to that in 1998?
Offer a very short reply. 2.28. What is the ratio of the Aid flow from UN agencies (US$) in Central Europe in 1996 to that in 1999?
Your answer should be compact. 1.17. What is the ratio of the Aid flow from UN agencies (US$) of Middle income in 1996 to that in 1999?
Ensure brevity in your answer.  1.08. What is the ratio of the Aid flow from UN agencies (US$) of Namibia in 1996 to that in 1999?
Your answer should be compact. 0.34. What is the ratio of the Aid flow from UN agencies (US$) of Thailand in 1996 to that in 1999?
Provide a short and direct response. 2.85. What is the ratio of the Aid flow from UN agencies (US$) in Central Europe in 1997 to that in 1998?
Ensure brevity in your answer.  1.01. What is the ratio of the Aid flow from UN agencies (US$) of Middle income in 1997 to that in 1998?
Your answer should be compact. 1.11. What is the ratio of the Aid flow from UN agencies (US$) of Namibia in 1997 to that in 1998?
Offer a terse response. 0.87. What is the ratio of the Aid flow from UN agencies (US$) of Thailand in 1997 to that in 1998?
Provide a succinct answer. 1.68. What is the ratio of the Aid flow from UN agencies (US$) in Central Europe in 1997 to that in 1999?
Your answer should be very brief. 1.07. What is the ratio of the Aid flow from UN agencies (US$) in Middle income in 1997 to that in 1999?
Your answer should be compact. 1.02. What is the ratio of the Aid flow from UN agencies (US$) in Namibia in 1997 to that in 1999?
Make the answer very short. 0.38. What is the ratio of the Aid flow from UN agencies (US$) in Thailand in 1997 to that in 1999?
Offer a very short reply. 2.11. What is the ratio of the Aid flow from UN agencies (US$) of Central Europe in 1998 to that in 1999?
Give a very brief answer. 1.06. What is the ratio of the Aid flow from UN agencies (US$) in Middle income in 1998 to that in 1999?
Offer a very short reply. 0.92. What is the ratio of the Aid flow from UN agencies (US$) in Namibia in 1998 to that in 1999?
Ensure brevity in your answer.  0.44. What is the ratio of the Aid flow from UN agencies (US$) of Thailand in 1998 to that in 1999?
Offer a terse response. 1.25. What is the difference between the highest and the second highest Aid flow from UN agencies (US$) in Central Europe?
Your answer should be very brief. 6.12e+07. What is the difference between the highest and the second highest Aid flow from UN agencies (US$) of Middle income?
Keep it short and to the point. 6.41e+07. What is the difference between the highest and the second highest Aid flow from UN agencies (US$) in Namibia?
Your response must be concise. 1.23e+06. What is the difference between the highest and the second highest Aid flow from UN agencies (US$) in Thailand?
Provide a short and direct response. 6.69e+06. What is the difference between the highest and the lowest Aid flow from UN agencies (US$) in Central Europe?
Make the answer very short. 6.68e+07. What is the difference between the highest and the lowest Aid flow from UN agencies (US$) in Middle income?
Offer a very short reply. 2.80e+08. What is the difference between the highest and the lowest Aid flow from UN agencies (US$) of Namibia?
Offer a terse response. 1.54e+06. What is the difference between the highest and the lowest Aid flow from UN agencies (US$) of Thailand?
Your response must be concise. 1.10e+07. 